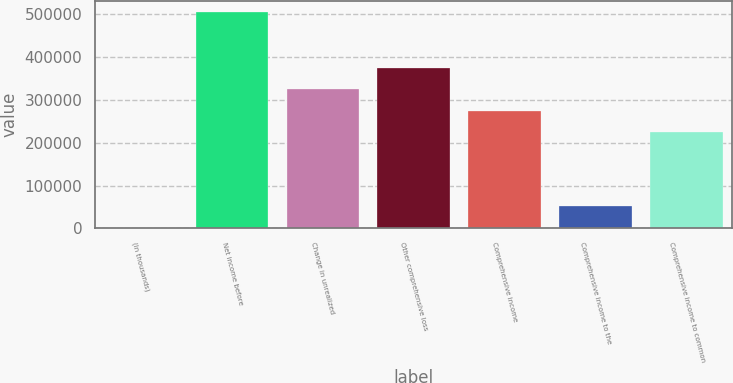Convert chart. <chart><loc_0><loc_0><loc_500><loc_500><bar_chart><fcel>(In thousands)<fcel>Net income before<fcel>Change in unrealized<fcel>Other comprehensive loss<fcel>Comprehensive income<fcel>Comprehensive income to the<fcel>Comprehensive income to common<nl><fcel>2013<fcel>505301<fcel>324343<fcel>374671<fcel>274014<fcel>52341.8<fcel>223685<nl></chart> 